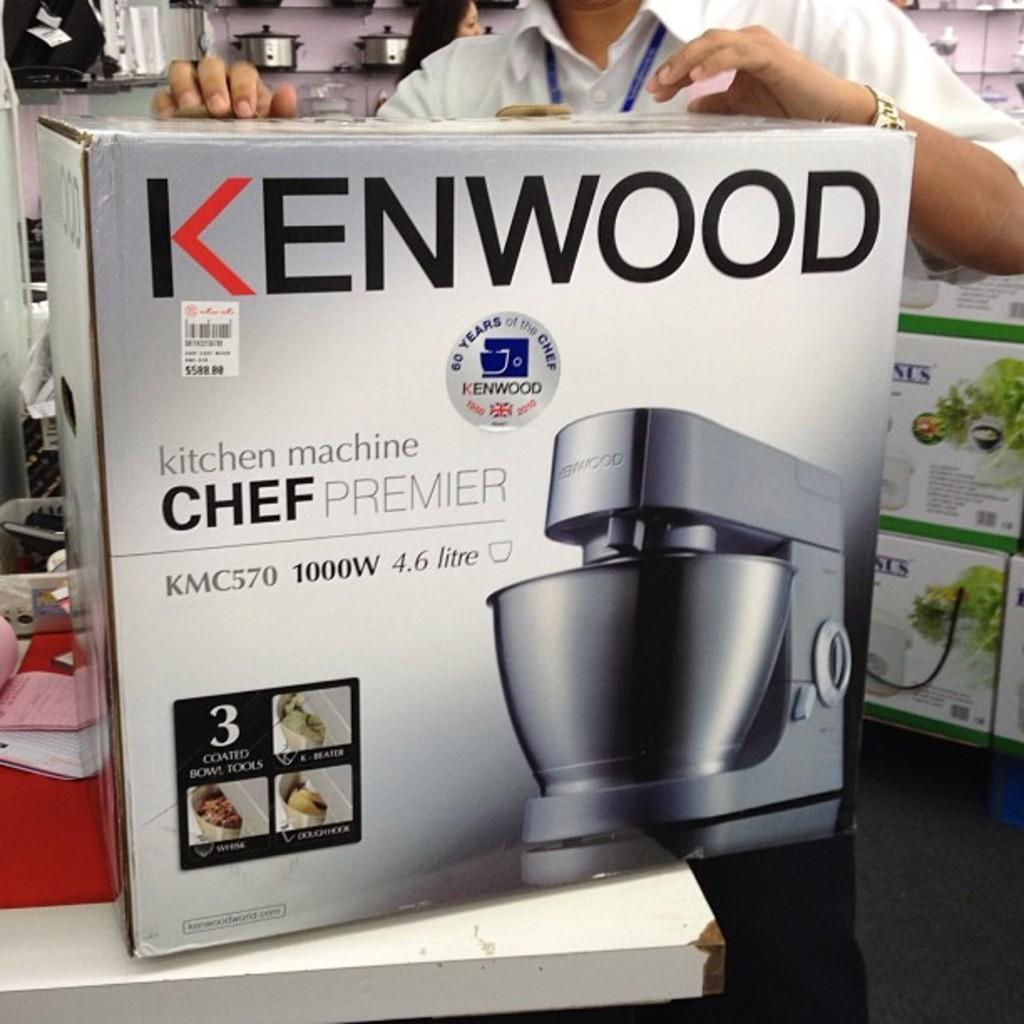<image>
Provide a brief description of the given image. A person is holding a Kenwood branded blender on a table in its original packaging. 